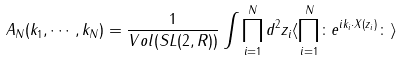Convert formula to latex. <formula><loc_0><loc_0><loc_500><loc_500>A _ { N } ( k _ { 1 } , \cdots , k _ { N } ) = \frac { 1 } { V o l ( S L ( 2 , R ) ) } \int \prod _ { i = 1 } ^ { N } d ^ { 2 } z _ { i } \langle \prod _ { i = 1 } ^ { N } \colon e ^ { i k _ { i } \cdot X ( z _ { i } ) } \colon \rangle</formula> 